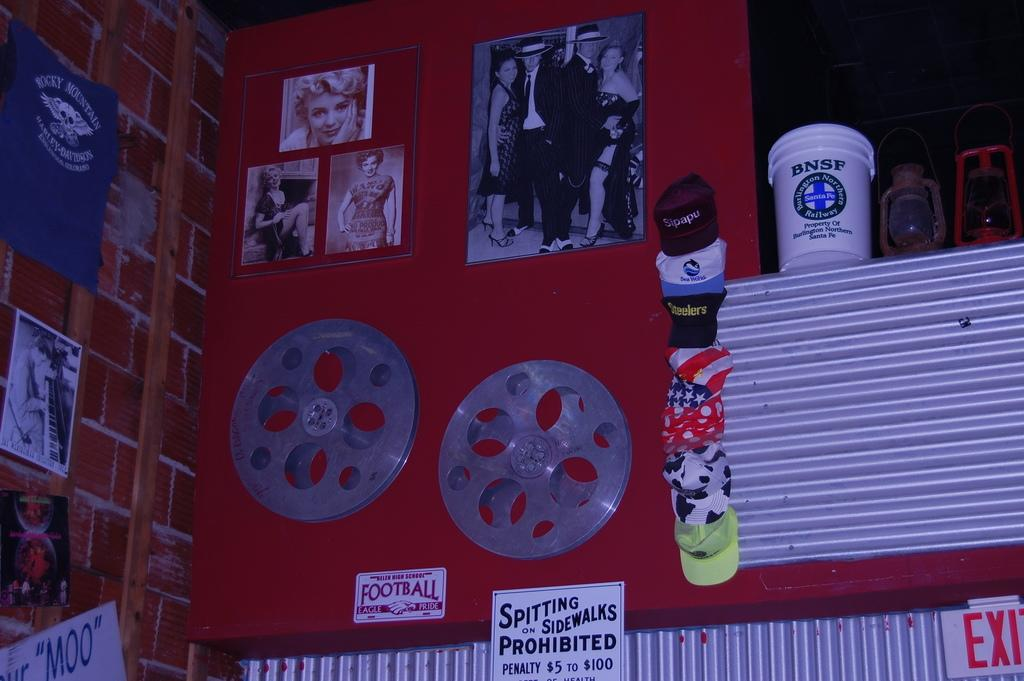<image>
Present a compact description of the photo's key features. Wall full of items including a sign that says "Spitting on Sidewalks Prohibited". 